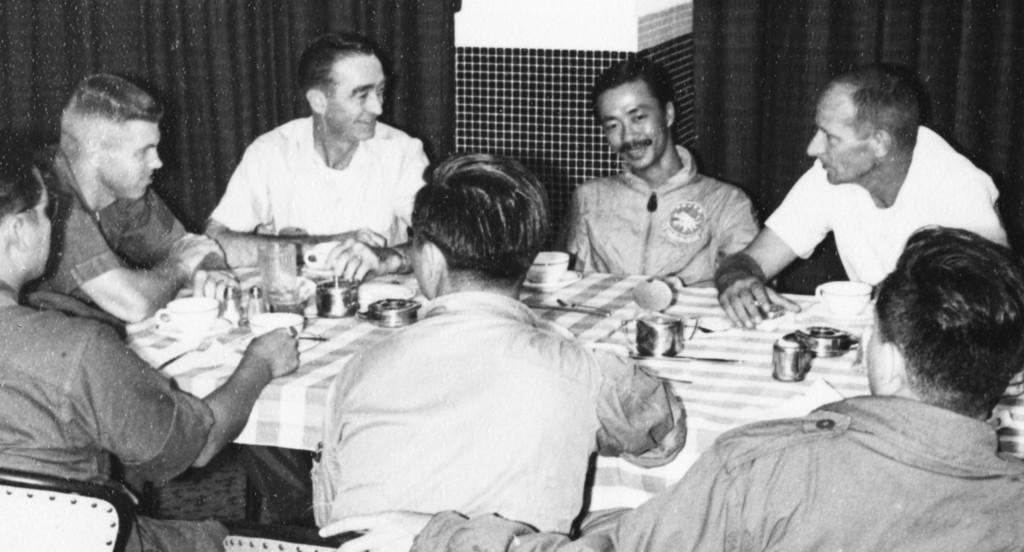In one or two sentences, can you explain what this image depicts? There are many persons sitting around a table. On the table there are plates, cup, saucer, glasses, and a tablecloth. In the background there is a curtain and a wall. And there are chairs in this room. 